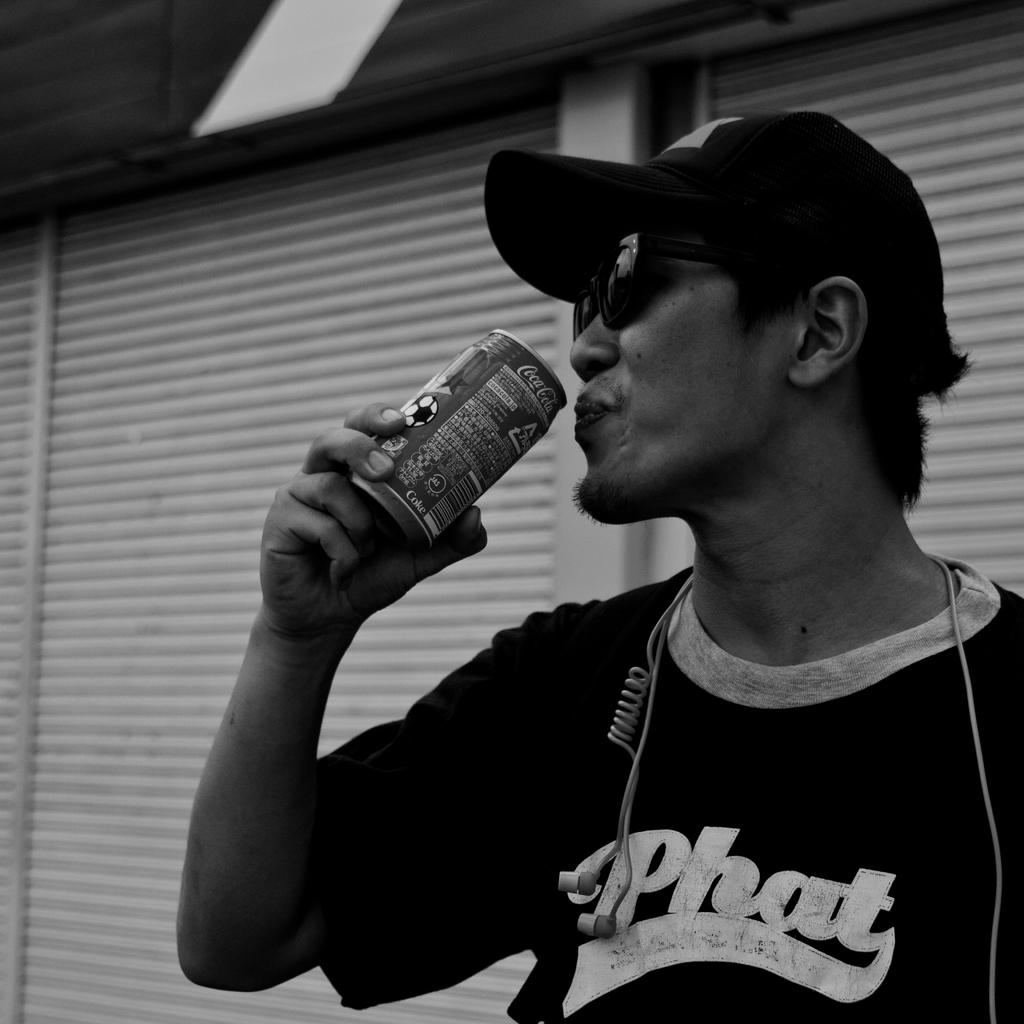What is the man in the image doing? The man is standing in the image. What is the man wearing on his head? The man is wearing a hat. What type of eyewear is the man wearing? The man is wearing black color goggles. What is the man holding in the image? The man is holding a coke can. What can be seen in the background of the image? There are shutters visible in the background of the image. What shape is the pickle in the image? There is no pickle present in the image. How many nets are visible in the image? There are no nets visible in the image. 